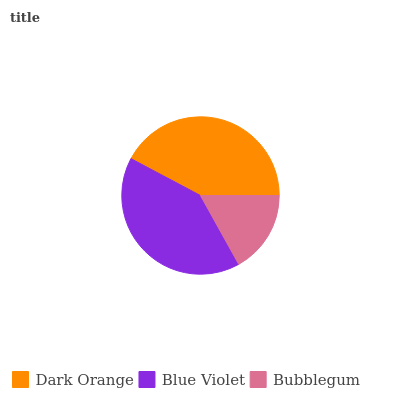Is Bubblegum the minimum?
Answer yes or no. Yes. Is Dark Orange the maximum?
Answer yes or no. Yes. Is Blue Violet the minimum?
Answer yes or no. No. Is Blue Violet the maximum?
Answer yes or no. No. Is Dark Orange greater than Blue Violet?
Answer yes or no. Yes. Is Blue Violet less than Dark Orange?
Answer yes or no. Yes. Is Blue Violet greater than Dark Orange?
Answer yes or no. No. Is Dark Orange less than Blue Violet?
Answer yes or no. No. Is Blue Violet the high median?
Answer yes or no. Yes. Is Blue Violet the low median?
Answer yes or no. Yes. Is Dark Orange the high median?
Answer yes or no. No. Is Dark Orange the low median?
Answer yes or no. No. 